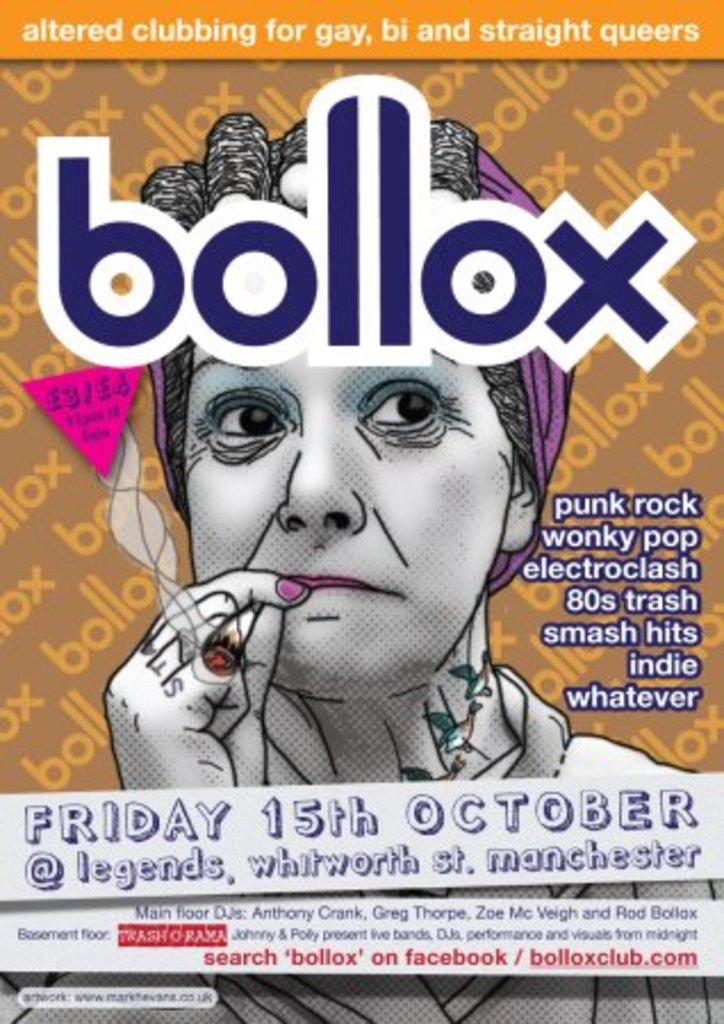<image>
Create a compact narrative representing the image presented. a poster for Bollox on Friday 15th October in Manchester 